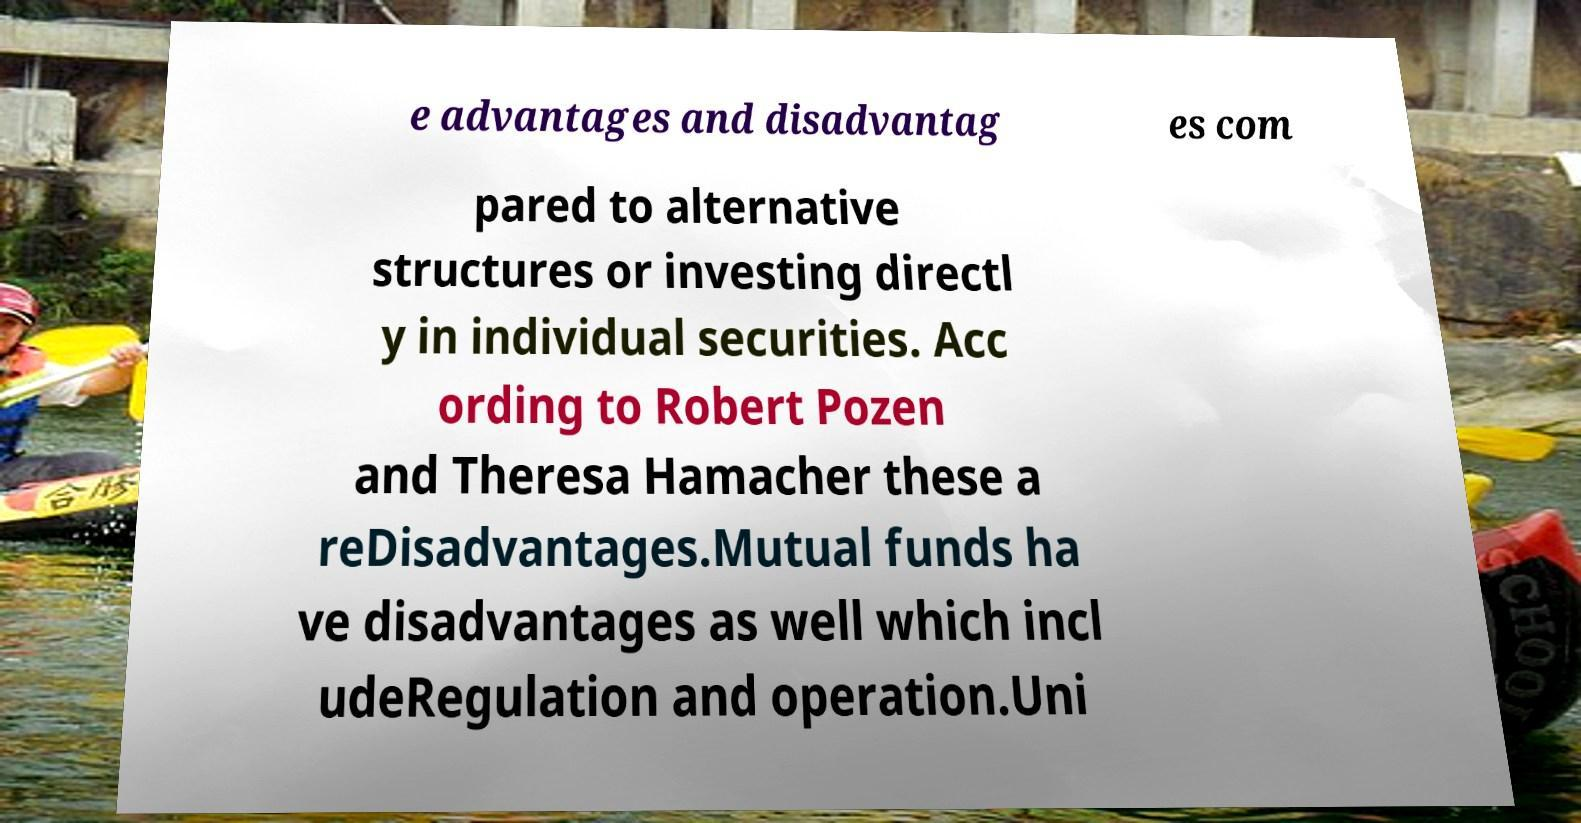Please read and relay the text visible in this image. What does it say? e advantages and disadvantag es com pared to alternative structures or investing directl y in individual securities. Acc ording to Robert Pozen and Theresa Hamacher these a reDisadvantages.Mutual funds ha ve disadvantages as well which incl udeRegulation and operation.Uni 